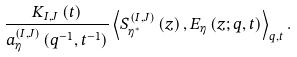Convert formula to latex. <formula><loc_0><loc_0><loc_500><loc_500>\frac { K _ { I , J } \left ( t \right ) } { a _ { \eta } ^ { \left ( I , J \right ) } \left ( q ^ { - 1 } , t ^ { - 1 } \right ) } \left \langle S _ { \eta ^ { \ast } } ^ { \left ( I , J \right ) } \left ( z \right ) , E _ { \eta } \left ( z ; q , t \right ) \right \rangle _ { q , t } .</formula> 